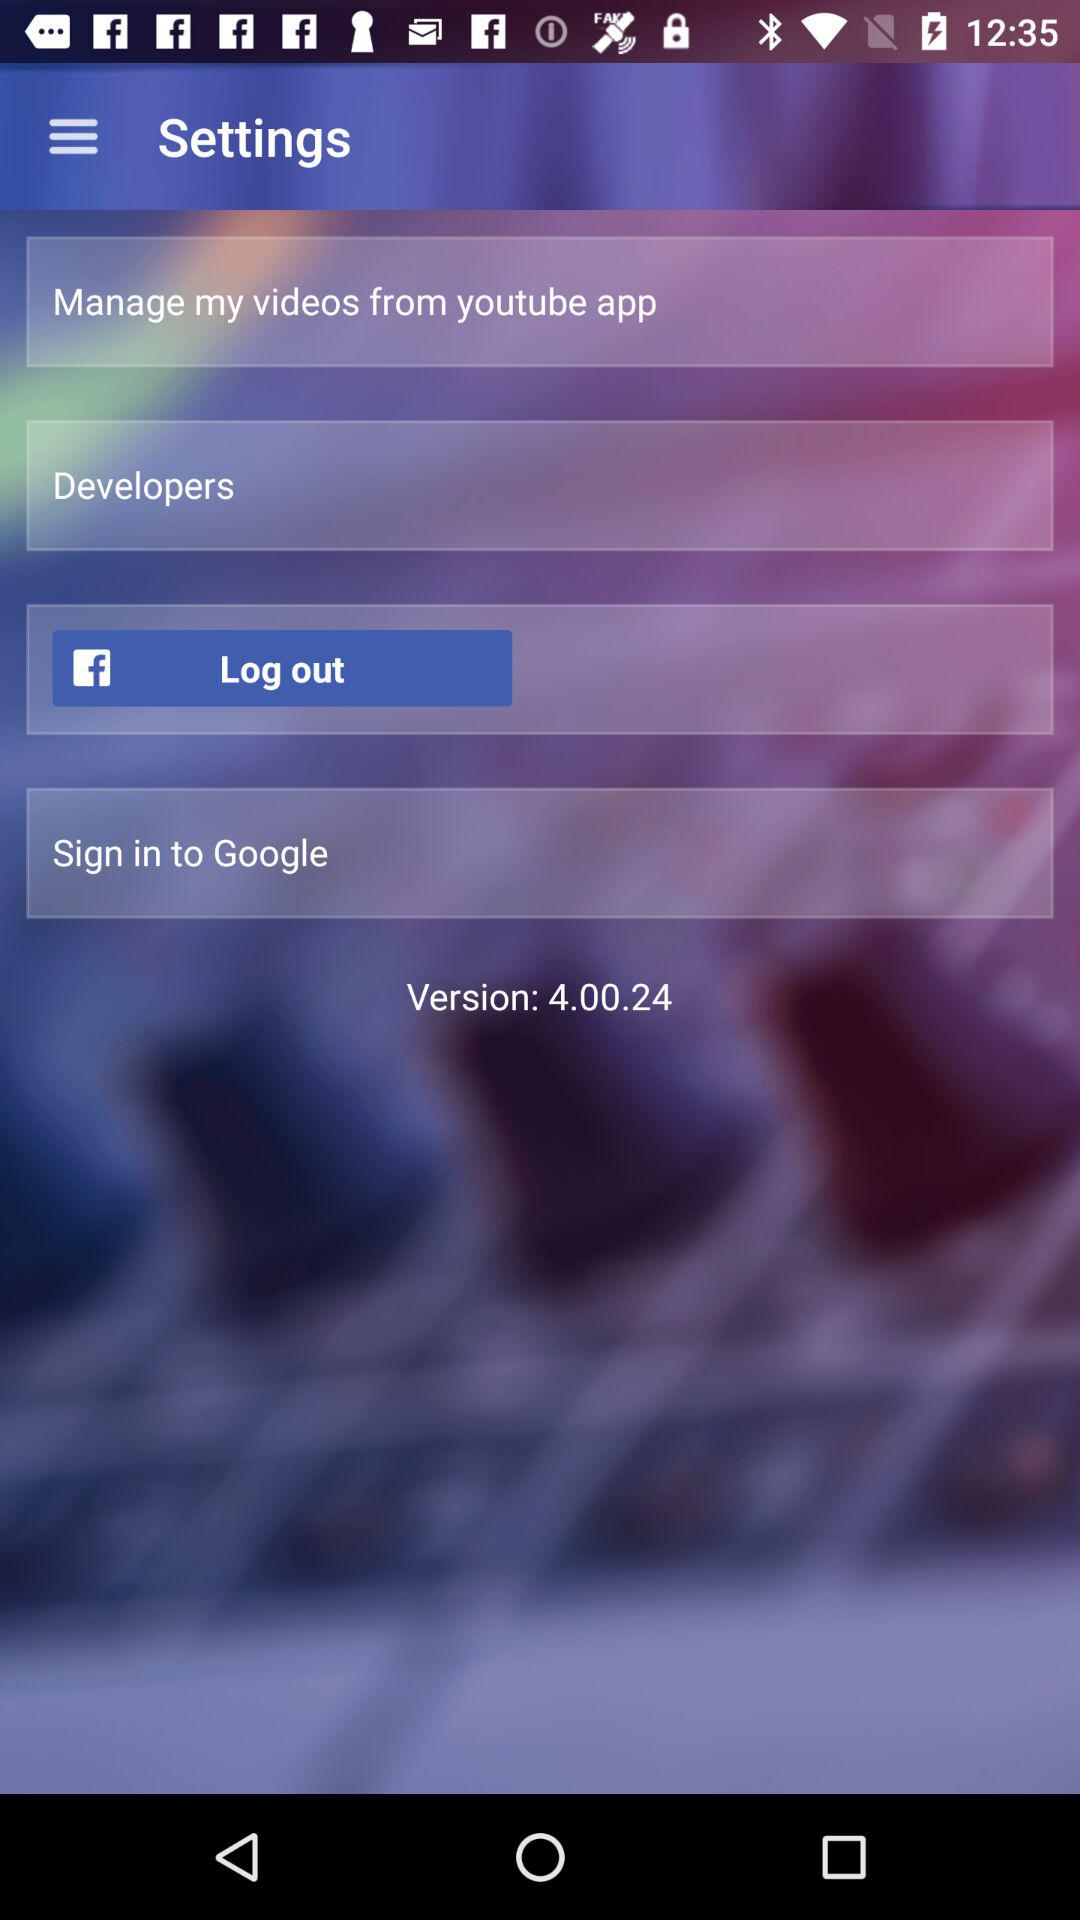What application can be used to sign in to the profile? You can sign in to the profile with "Google". 